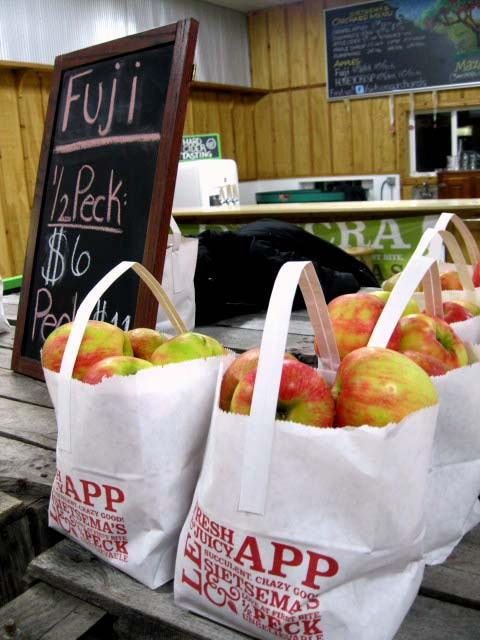How many sinks are visible? The question is about sinks, however, there are no sinks visible in this image. It depicts several bags of apples, a sign for 'Fuji' apples, and part of a wooden interior that resembles a market or farm stand. 